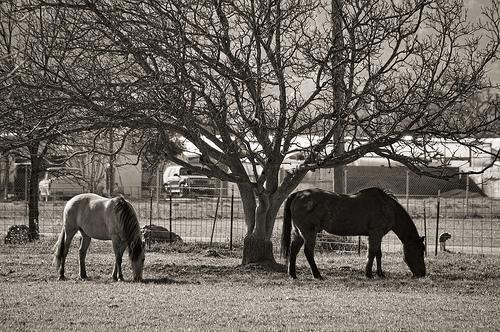How many horses are there?
Give a very brief answer. 2. How many horses are to the right of the tree?
Give a very brief answer. 1. 